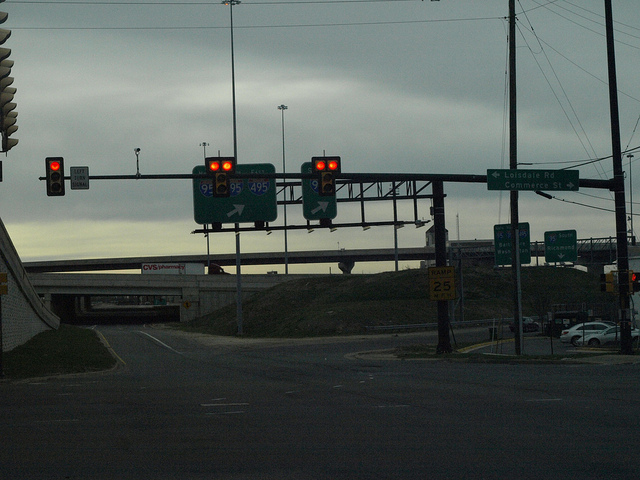<image>How cold is it? It is unknown how cold it is. Some people say it's mild, others say it's chilly. How cold is it? I don't know how cold it is. It can be described as mild, chilly, not too cold or slightly cold. 